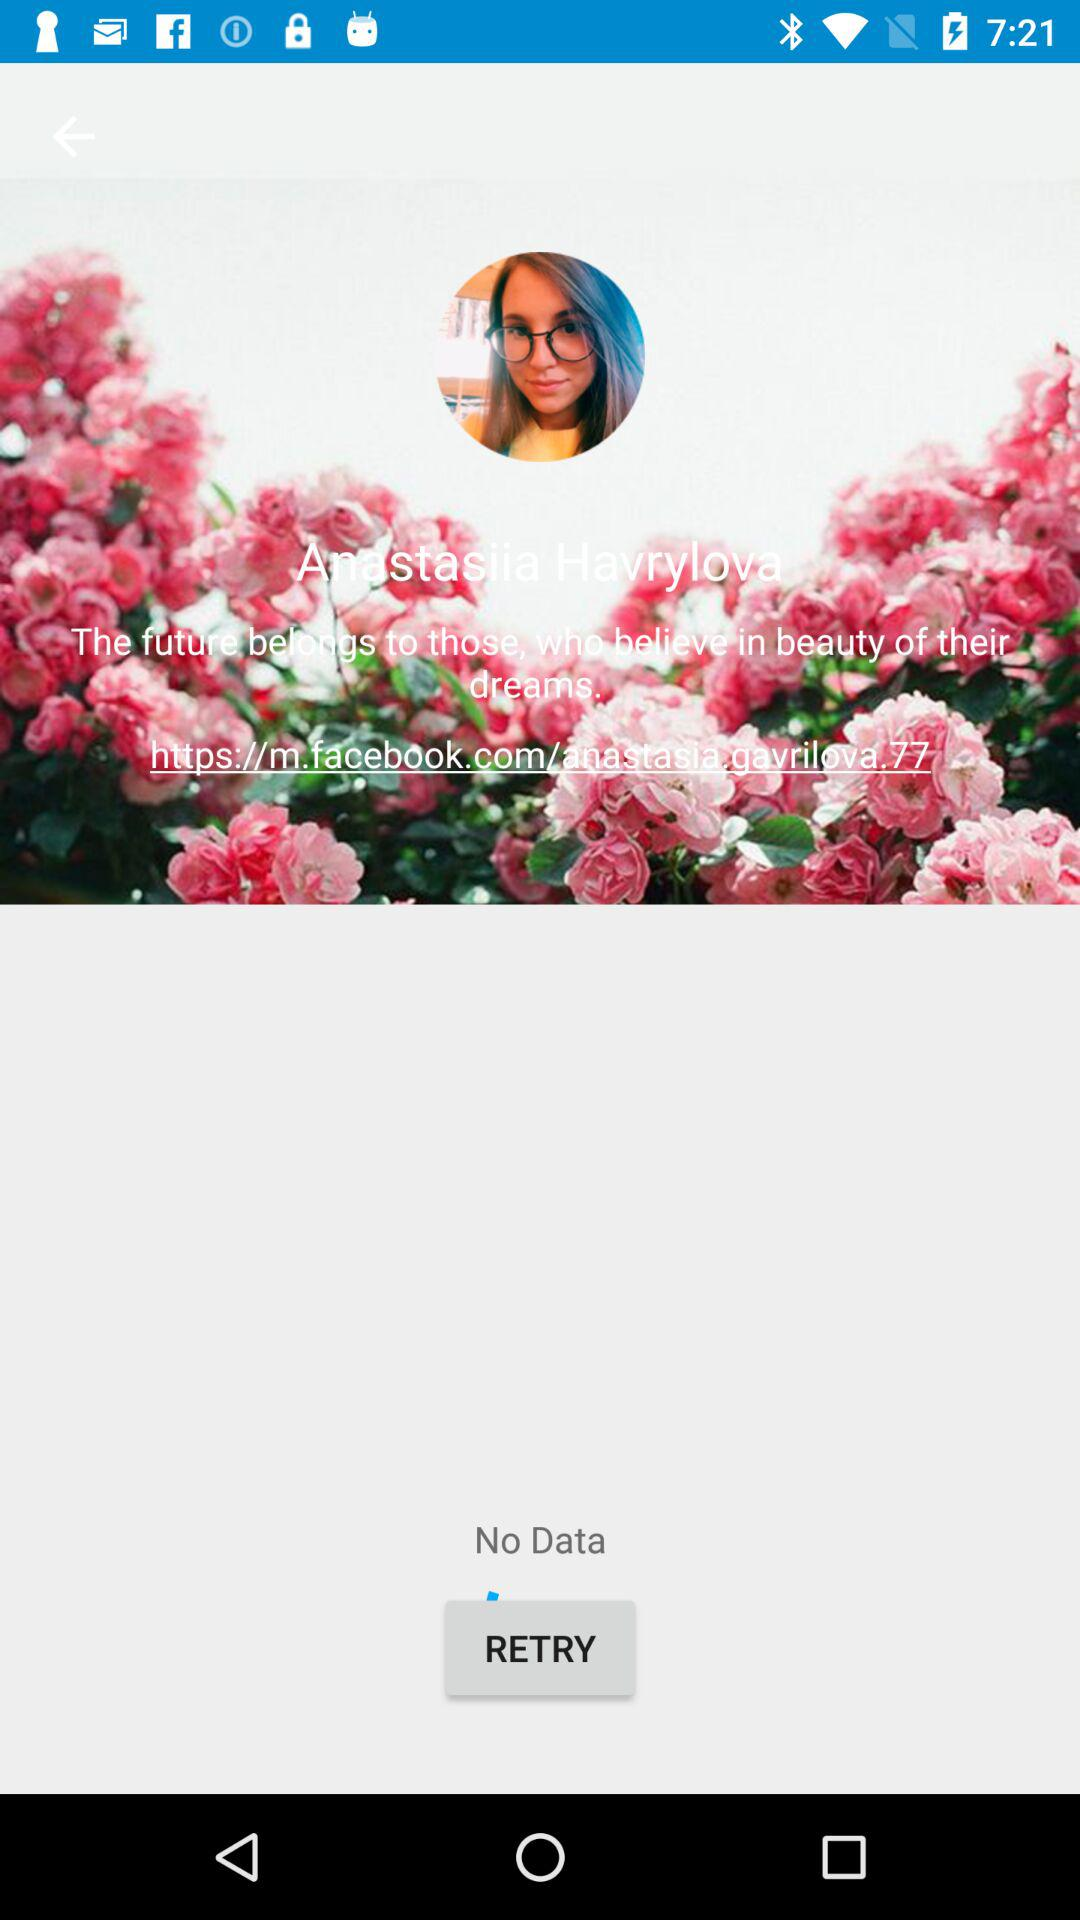Is there any data shown? There is no data shown. 